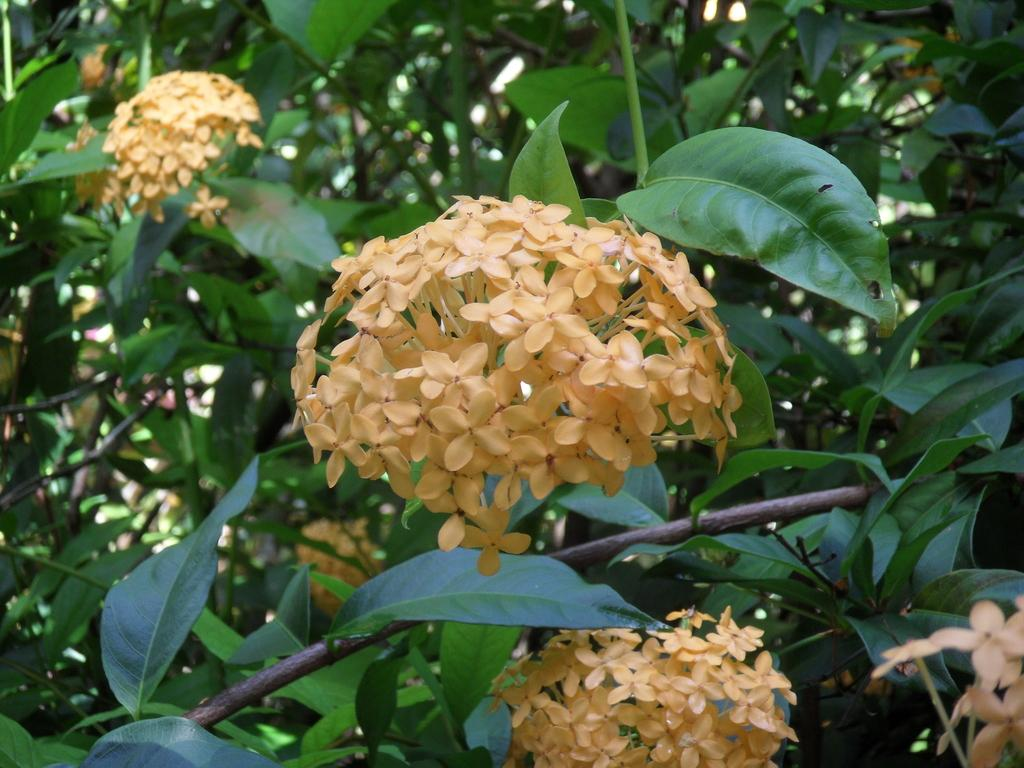What type of plant life can be seen in the image? There are flowers, leaves, and branches in the image. Can you describe the different parts of the plants in the image? The flowers are colorful and may have petals, while the leaves are green and may have veins. The branches are woody and provide support for the leaves and flowers. What type of rice can be seen in the image? There is no rice present in the image; it features flowers, leaves, and branches. What kind of noise can be heard coming from the flowers in the image? There is no noise coming from the flowers in the image, as flowers do not produce sound. 